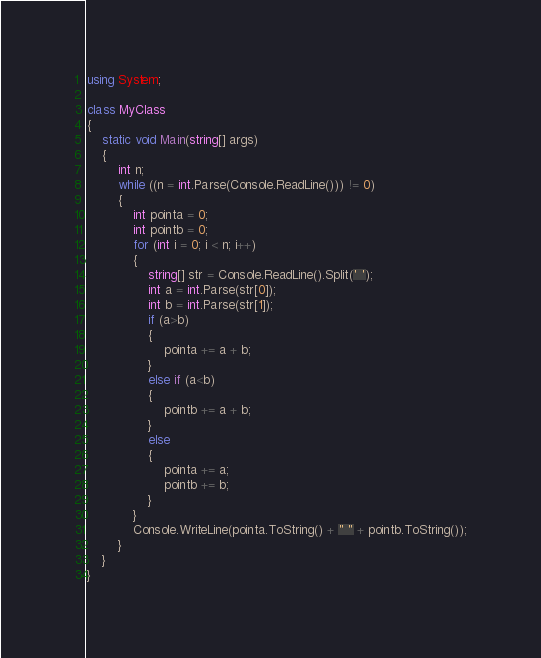Convert code to text. <code><loc_0><loc_0><loc_500><loc_500><_C#_>using System;

class MyClass
{
    static void Main(string[] args)
    {
        int n;
        while ((n = int.Parse(Console.ReadLine())) != 0)
        {
            int pointa = 0;
            int pointb = 0;
            for (int i = 0; i < n; i++)
            {
                string[] str = Console.ReadLine().Split(' ');
                int a = int.Parse(str[0]);
                int b = int.Parse(str[1]);
                if (a>b)
                {
                    pointa += a + b;
                }
                else if (a<b)
                {
                    pointb += a + b;
                }
                else
                {
                    pointa += a;
                    pointb += b;
                }
            }
            Console.WriteLine(pointa.ToString() + " " + pointb.ToString());
        }
    }
}
</code> 